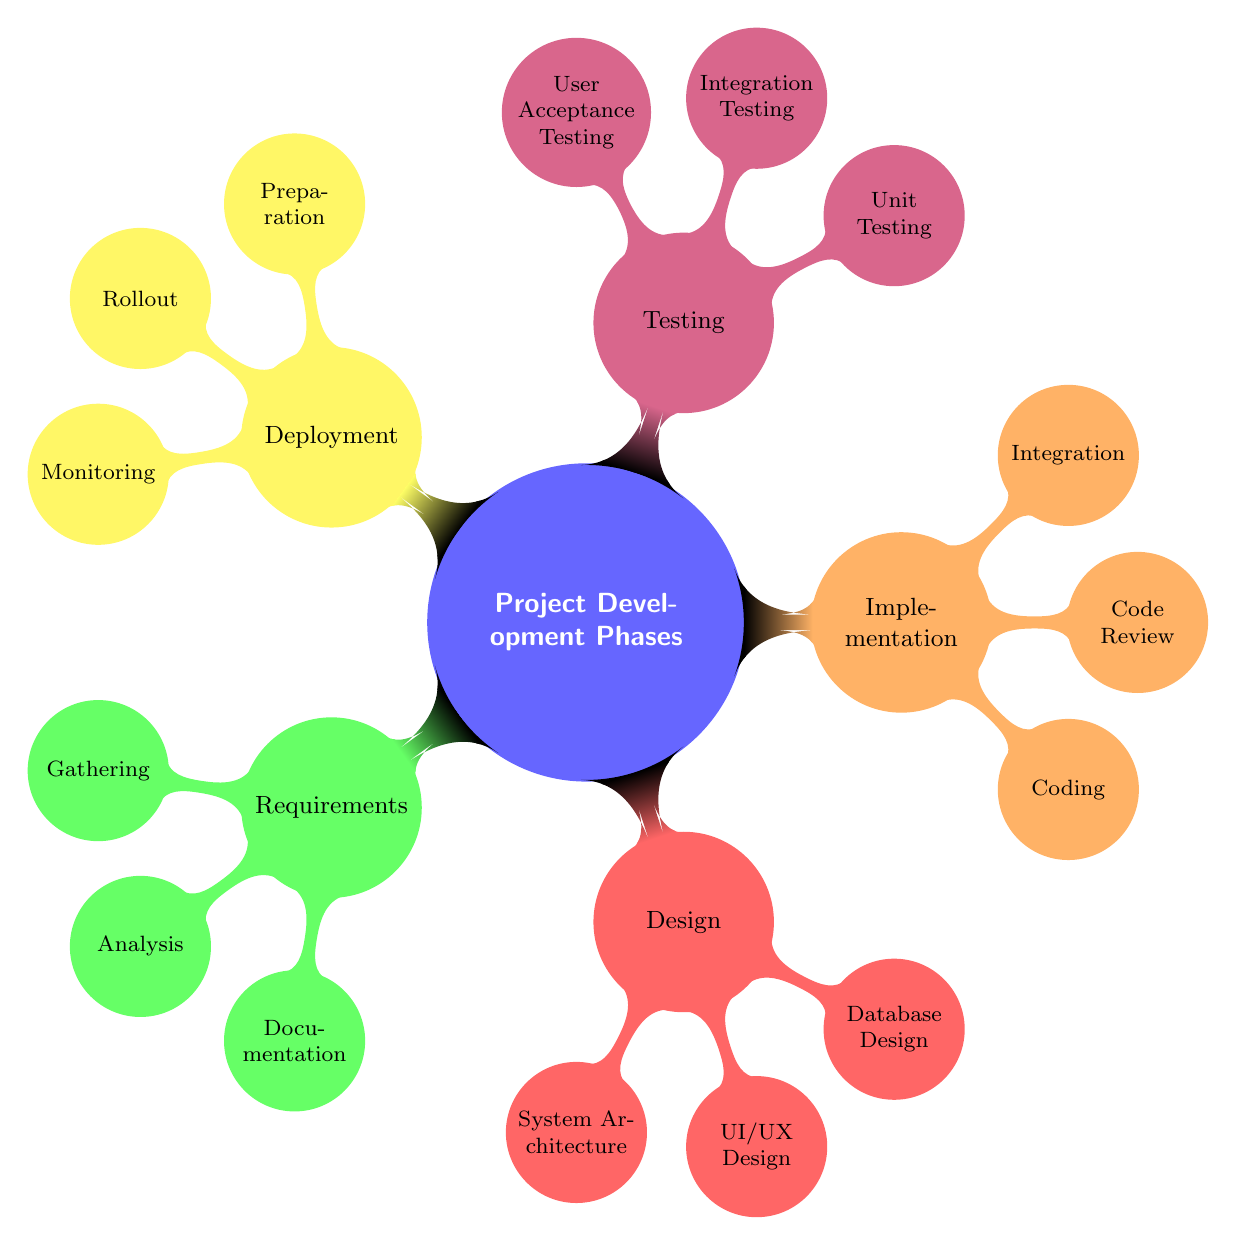What are the three main phases under "Implementation"? The implementation phase includes three sub-nodes: Coding, Code Review, and Integration. Each of these represents a key area within the implementation process.
Answer: Coding, Code Review, Integration How many sub-nodes are under "Testing"? Under the testing phase, there are three sub-nodes: Unit Testing, Integration Testing, and User Acceptance Testing. This gives us three areas of focus for testing within the project development phases.
Answer: 3 Which node is related to "Stakeholder Interviews"? The "Gathering" node under "Requirements" is specifically related to Stakeholder Interviews, as it involves collecting information from stakeholders to understand their needs.
Answer: Gathering What is the main focus of the "Design" phase? The design phase focuses on several aspects, but primarily it involves creating the System Architecture, UI/UX Design, and Database Design. These aspects guide the overall structure and usability of the project.
Answer: System Architecture, UI/UX Design, Database Design What tool is associated with "Continuous Integration"? Continuous Integration is associated with the "Integration" node under "Implementation", specifically citing Jenkins as a tool used for this purpose, which facilitates the integration process.
Answer: Jenkins Which phase comes before "Deployment"? The phase that directly precedes deployment in the diagram is "Testing". This order indicates that thorough testing should be conducted before the deployment of any project.
Answer: Testing What is the purpose of "Beta Testing"? Beta Testing is a form of user acceptance testing where the software is tested by real users in a real environment to identify any remaining issues before the final rollout.
Answer: User Acceptance Testing How are "Wireframes" related to the design phase? Wireframes are specifically mentioned under the "UI/UX Design" sub-node of the "Design" phase, illustrating their function as a tool for outlining user interface designs and experiences.
Answer: UI/UX Design What does "Monitoring" relate to in the deployment phase? Monitoring is related to the "Deployment" phase, highlighting the importance of tracking the application’s performance and health post-deployment, specifically mentioning tools like New Relic.
Answer: Monitoring 